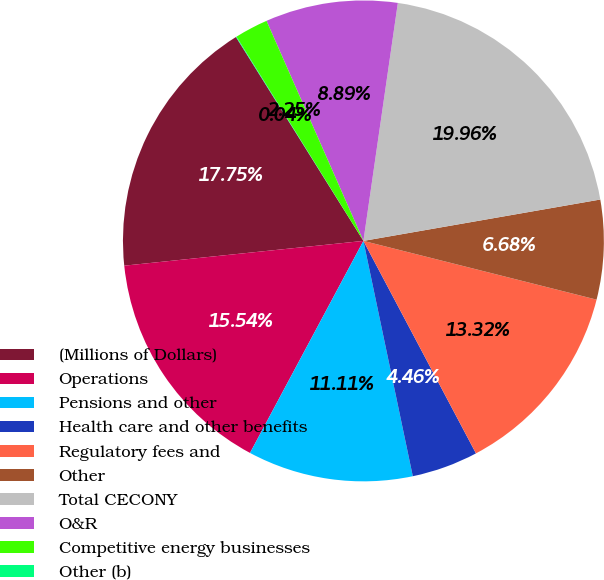Convert chart to OTSL. <chart><loc_0><loc_0><loc_500><loc_500><pie_chart><fcel>(Millions of Dollars)<fcel>Operations<fcel>Pensions and other<fcel>Health care and other benefits<fcel>Regulatory fees and<fcel>Other<fcel>Total CECONY<fcel>O&R<fcel>Competitive energy businesses<fcel>Other (b)<nl><fcel>17.75%<fcel>15.54%<fcel>11.11%<fcel>4.46%<fcel>13.32%<fcel>6.68%<fcel>19.96%<fcel>8.89%<fcel>2.25%<fcel>0.04%<nl></chart> 